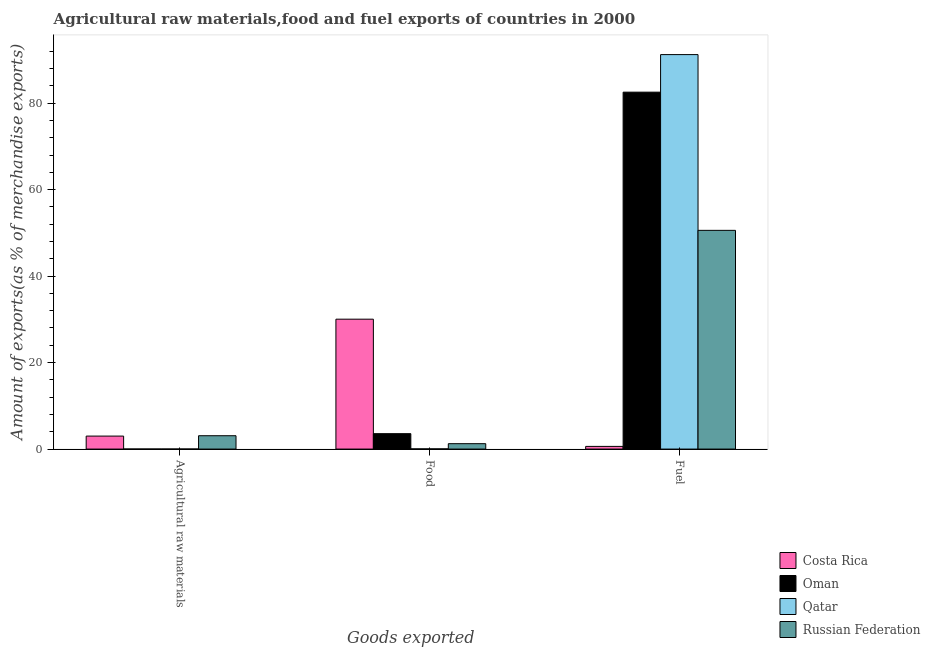How many different coloured bars are there?
Offer a terse response. 4. How many groups of bars are there?
Ensure brevity in your answer.  3. Are the number of bars per tick equal to the number of legend labels?
Make the answer very short. Yes. Are the number of bars on each tick of the X-axis equal?
Offer a very short reply. Yes. What is the label of the 1st group of bars from the left?
Your answer should be compact. Agricultural raw materials. What is the percentage of raw materials exports in Russian Federation?
Your response must be concise. 3.09. Across all countries, what is the maximum percentage of food exports?
Provide a short and direct response. 30.04. Across all countries, what is the minimum percentage of food exports?
Provide a succinct answer. 0.05. In which country was the percentage of raw materials exports maximum?
Provide a short and direct response. Russian Federation. In which country was the percentage of raw materials exports minimum?
Give a very brief answer. Qatar. What is the total percentage of food exports in the graph?
Keep it short and to the point. 34.9. What is the difference between the percentage of fuel exports in Qatar and that in Russian Federation?
Provide a succinct answer. 40.64. What is the difference between the percentage of raw materials exports in Qatar and the percentage of fuel exports in Russian Federation?
Offer a very short reply. -50.57. What is the average percentage of raw materials exports per country?
Make the answer very short. 1.53. What is the difference between the percentage of fuel exports and percentage of food exports in Oman?
Offer a very short reply. 78.97. In how many countries, is the percentage of raw materials exports greater than 12 %?
Keep it short and to the point. 0. What is the ratio of the percentage of fuel exports in Oman to that in Qatar?
Your answer should be compact. 0.9. Is the percentage of fuel exports in Costa Rica less than that in Qatar?
Offer a terse response. Yes. Is the difference between the percentage of food exports in Qatar and Russian Federation greater than the difference between the percentage of fuel exports in Qatar and Russian Federation?
Provide a succinct answer. No. What is the difference between the highest and the second highest percentage of raw materials exports?
Your answer should be very brief. 0.08. What is the difference between the highest and the lowest percentage of raw materials exports?
Provide a succinct answer. 3.08. In how many countries, is the percentage of fuel exports greater than the average percentage of fuel exports taken over all countries?
Your answer should be compact. 2. Is the sum of the percentage of fuel exports in Oman and Russian Federation greater than the maximum percentage of raw materials exports across all countries?
Ensure brevity in your answer.  Yes. What does the 3rd bar from the left in Fuel represents?
Give a very brief answer. Qatar. What does the 2nd bar from the right in Fuel represents?
Your answer should be very brief. Qatar. How many bars are there?
Your response must be concise. 12. Are all the bars in the graph horizontal?
Your answer should be compact. No. Are the values on the major ticks of Y-axis written in scientific E-notation?
Your answer should be very brief. No. Does the graph contain any zero values?
Your response must be concise. No. Does the graph contain grids?
Offer a very short reply. No. Where does the legend appear in the graph?
Keep it short and to the point. Bottom right. How many legend labels are there?
Offer a terse response. 4. What is the title of the graph?
Keep it short and to the point. Agricultural raw materials,food and fuel exports of countries in 2000. What is the label or title of the X-axis?
Offer a very short reply. Goods exported. What is the label or title of the Y-axis?
Your response must be concise. Amount of exports(as % of merchandise exports). What is the Amount of exports(as % of merchandise exports) in Costa Rica in Agricultural raw materials?
Offer a terse response. 3. What is the Amount of exports(as % of merchandise exports) in Oman in Agricultural raw materials?
Your response must be concise. 0.01. What is the Amount of exports(as % of merchandise exports) in Qatar in Agricultural raw materials?
Your response must be concise. 0.01. What is the Amount of exports(as % of merchandise exports) in Russian Federation in Agricultural raw materials?
Your answer should be compact. 3.09. What is the Amount of exports(as % of merchandise exports) in Costa Rica in Food?
Offer a terse response. 30.04. What is the Amount of exports(as % of merchandise exports) of Oman in Food?
Your answer should be compact. 3.56. What is the Amount of exports(as % of merchandise exports) of Qatar in Food?
Make the answer very short. 0.05. What is the Amount of exports(as % of merchandise exports) in Russian Federation in Food?
Your answer should be very brief. 1.25. What is the Amount of exports(as % of merchandise exports) of Costa Rica in Fuel?
Your answer should be very brief. 0.62. What is the Amount of exports(as % of merchandise exports) of Oman in Fuel?
Offer a terse response. 82.54. What is the Amount of exports(as % of merchandise exports) in Qatar in Fuel?
Provide a succinct answer. 91.23. What is the Amount of exports(as % of merchandise exports) in Russian Federation in Fuel?
Your answer should be compact. 50.58. Across all Goods exported, what is the maximum Amount of exports(as % of merchandise exports) of Costa Rica?
Give a very brief answer. 30.04. Across all Goods exported, what is the maximum Amount of exports(as % of merchandise exports) in Oman?
Your answer should be compact. 82.54. Across all Goods exported, what is the maximum Amount of exports(as % of merchandise exports) of Qatar?
Give a very brief answer. 91.23. Across all Goods exported, what is the maximum Amount of exports(as % of merchandise exports) in Russian Federation?
Your answer should be compact. 50.58. Across all Goods exported, what is the minimum Amount of exports(as % of merchandise exports) of Costa Rica?
Your answer should be very brief. 0.62. Across all Goods exported, what is the minimum Amount of exports(as % of merchandise exports) in Oman?
Make the answer very short. 0.01. Across all Goods exported, what is the minimum Amount of exports(as % of merchandise exports) in Qatar?
Your answer should be compact. 0.01. Across all Goods exported, what is the minimum Amount of exports(as % of merchandise exports) in Russian Federation?
Ensure brevity in your answer.  1.25. What is the total Amount of exports(as % of merchandise exports) of Costa Rica in the graph?
Your answer should be very brief. 33.66. What is the total Amount of exports(as % of merchandise exports) of Oman in the graph?
Ensure brevity in your answer.  86.12. What is the total Amount of exports(as % of merchandise exports) in Qatar in the graph?
Offer a terse response. 91.29. What is the total Amount of exports(as % of merchandise exports) of Russian Federation in the graph?
Your response must be concise. 54.92. What is the difference between the Amount of exports(as % of merchandise exports) in Costa Rica in Agricultural raw materials and that in Food?
Your answer should be compact. -27.03. What is the difference between the Amount of exports(as % of merchandise exports) in Oman in Agricultural raw materials and that in Food?
Your response must be concise. -3.55. What is the difference between the Amount of exports(as % of merchandise exports) in Qatar in Agricultural raw materials and that in Food?
Your answer should be compact. -0.03. What is the difference between the Amount of exports(as % of merchandise exports) of Russian Federation in Agricultural raw materials and that in Food?
Offer a very short reply. 1.84. What is the difference between the Amount of exports(as % of merchandise exports) of Costa Rica in Agricultural raw materials and that in Fuel?
Your answer should be very brief. 2.39. What is the difference between the Amount of exports(as % of merchandise exports) in Oman in Agricultural raw materials and that in Fuel?
Offer a terse response. -82.52. What is the difference between the Amount of exports(as % of merchandise exports) in Qatar in Agricultural raw materials and that in Fuel?
Your answer should be compact. -91.21. What is the difference between the Amount of exports(as % of merchandise exports) of Russian Federation in Agricultural raw materials and that in Fuel?
Offer a terse response. -47.49. What is the difference between the Amount of exports(as % of merchandise exports) in Costa Rica in Food and that in Fuel?
Ensure brevity in your answer.  29.42. What is the difference between the Amount of exports(as % of merchandise exports) of Oman in Food and that in Fuel?
Ensure brevity in your answer.  -78.97. What is the difference between the Amount of exports(as % of merchandise exports) in Qatar in Food and that in Fuel?
Keep it short and to the point. -91.18. What is the difference between the Amount of exports(as % of merchandise exports) of Russian Federation in Food and that in Fuel?
Provide a succinct answer. -49.33. What is the difference between the Amount of exports(as % of merchandise exports) in Costa Rica in Agricultural raw materials and the Amount of exports(as % of merchandise exports) in Oman in Food?
Make the answer very short. -0.56. What is the difference between the Amount of exports(as % of merchandise exports) of Costa Rica in Agricultural raw materials and the Amount of exports(as % of merchandise exports) of Qatar in Food?
Offer a terse response. 2.96. What is the difference between the Amount of exports(as % of merchandise exports) in Costa Rica in Agricultural raw materials and the Amount of exports(as % of merchandise exports) in Russian Federation in Food?
Offer a very short reply. 1.76. What is the difference between the Amount of exports(as % of merchandise exports) in Oman in Agricultural raw materials and the Amount of exports(as % of merchandise exports) in Qatar in Food?
Ensure brevity in your answer.  -0.03. What is the difference between the Amount of exports(as % of merchandise exports) in Oman in Agricultural raw materials and the Amount of exports(as % of merchandise exports) in Russian Federation in Food?
Your answer should be very brief. -1.23. What is the difference between the Amount of exports(as % of merchandise exports) in Qatar in Agricultural raw materials and the Amount of exports(as % of merchandise exports) in Russian Federation in Food?
Offer a terse response. -1.23. What is the difference between the Amount of exports(as % of merchandise exports) of Costa Rica in Agricultural raw materials and the Amount of exports(as % of merchandise exports) of Oman in Fuel?
Provide a succinct answer. -79.53. What is the difference between the Amount of exports(as % of merchandise exports) in Costa Rica in Agricultural raw materials and the Amount of exports(as % of merchandise exports) in Qatar in Fuel?
Provide a succinct answer. -88.22. What is the difference between the Amount of exports(as % of merchandise exports) of Costa Rica in Agricultural raw materials and the Amount of exports(as % of merchandise exports) of Russian Federation in Fuel?
Ensure brevity in your answer.  -47.58. What is the difference between the Amount of exports(as % of merchandise exports) in Oman in Agricultural raw materials and the Amount of exports(as % of merchandise exports) in Qatar in Fuel?
Provide a succinct answer. -91.21. What is the difference between the Amount of exports(as % of merchandise exports) of Oman in Agricultural raw materials and the Amount of exports(as % of merchandise exports) of Russian Federation in Fuel?
Provide a succinct answer. -50.57. What is the difference between the Amount of exports(as % of merchandise exports) of Qatar in Agricultural raw materials and the Amount of exports(as % of merchandise exports) of Russian Federation in Fuel?
Your answer should be very brief. -50.57. What is the difference between the Amount of exports(as % of merchandise exports) in Costa Rica in Food and the Amount of exports(as % of merchandise exports) in Oman in Fuel?
Provide a short and direct response. -52.5. What is the difference between the Amount of exports(as % of merchandise exports) in Costa Rica in Food and the Amount of exports(as % of merchandise exports) in Qatar in Fuel?
Make the answer very short. -61.19. What is the difference between the Amount of exports(as % of merchandise exports) in Costa Rica in Food and the Amount of exports(as % of merchandise exports) in Russian Federation in Fuel?
Your response must be concise. -20.54. What is the difference between the Amount of exports(as % of merchandise exports) in Oman in Food and the Amount of exports(as % of merchandise exports) in Qatar in Fuel?
Your answer should be very brief. -87.66. What is the difference between the Amount of exports(as % of merchandise exports) of Oman in Food and the Amount of exports(as % of merchandise exports) of Russian Federation in Fuel?
Your response must be concise. -47.02. What is the difference between the Amount of exports(as % of merchandise exports) in Qatar in Food and the Amount of exports(as % of merchandise exports) in Russian Federation in Fuel?
Provide a short and direct response. -50.53. What is the average Amount of exports(as % of merchandise exports) in Costa Rica per Goods exported?
Give a very brief answer. 11.22. What is the average Amount of exports(as % of merchandise exports) in Oman per Goods exported?
Ensure brevity in your answer.  28.71. What is the average Amount of exports(as % of merchandise exports) of Qatar per Goods exported?
Provide a short and direct response. 30.43. What is the average Amount of exports(as % of merchandise exports) in Russian Federation per Goods exported?
Offer a terse response. 18.31. What is the difference between the Amount of exports(as % of merchandise exports) in Costa Rica and Amount of exports(as % of merchandise exports) in Oman in Agricultural raw materials?
Keep it short and to the point. 2.99. What is the difference between the Amount of exports(as % of merchandise exports) of Costa Rica and Amount of exports(as % of merchandise exports) of Qatar in Agricultural raw materials?
Keep it short and to the point. 2.99. What is the difference between the Amount of exports(as % of merchandise exports) of Costa Rica and Amount of exports(as % of merchandise exports) of Russian Federation in Agricultural raw materials?
Give a very brief answer. -0.09. What is the difference between the Amount of exports(as % of merchandise exports) of Oman and Amount of exports(as % of merchandise exports) of Qatar in Agricultural raw materials?
Make the answer very short. 0. What is the difference between the Amount of exports(as % of merchandise exports) of Oman and Amount of exports(as % of merchandise exports) of Russian Federation in Agricultural raw materials?
Ensure brevity in your answer.  -3.08. What is the difference between the Amount of exports(as % of merchandise exports) in Qatar and Amount of exports(as % of merchandise exports) in Russian Federation in Agricultural raw materials?
Keep it short and to the point. -3.08. What is the difference between the Amount of exports(as % of merchandise exports) in Costa Rica and Amount of exports(as % of merchandise exports) in Oman in Food?
Offer a terse response. 26.47. What is the difference between the Amount of exports(as % of merchandise exports) in Costa Rica and Amount of exports(as % of merchandise exports) in Qatar in Food?
Provide a succinct answer. 29.99. What is the difference between the Amount of exports(as % of merchandise exports) of Costa Rica and Amount of exports(as % of merchandise exports) of Russian Federation in Food?
Offer a terse response. 28.79. What is the difference between the Amount of exports(as % of merchandise exports) of Oman and Amount of exports(as % of merchandise exports) of Qatar in Food?
Offer a terse response. 3.52. What is the difference between the Amount of exports(as % of merchandise exports) of Oman and Amount of exports(as % of merchandise exports) of Russian Federation in Food?
Your answer should be compact. 2.32. What is the difference between the Amount of exports(as % of merchandise exports) in Qatar and Amount of exports(as % of merchandise exports) in Russian Federation in Food?
Your response must be concise. -1.2. What is the difference between the Amount of exports(as % of merchandise exports) of Costa Rica and Amount of exports(as % of merchandise exports) of Oman in Fuel?
Offer a very short reply. -81.92. What is the difference between the Amount of exports(as % of merchandise exports) of Costa Rica and Amount of exports(as % of merchandise exports) of Qatar in Fuel?
Your answer should be compact. -90.61. What is the difference between the Amount of exports(as % of merchandise exports) of Costa Rica and Amount of exports(as % of merchandise exports) of Russian Federation in Fuel?
Provide a short and direct response. -49.96. What is the difference between the Amount of exports(as % of merchandise exports) in Oman and Amount of exports(as % of merchandise exports) in Qatar in Fuel?
Offer a very short reply. -8.69. What is the difference between the Amount of exports(as % of merchandise exports) of Oman and Amount of exports(as % of merchandise exports) of Russian Federation in Fuel?
Your response must be concise. 31.96. What is the difference between the Amount of exports(as % of merchandise exports) in Qatar and Amount of exports(as % of merchandise exports) in Russian Federation in Fuel?
Offer a terse response. 40.64. What is the ratio of the Amount of exports(as % of merchandise exports) in Costa Rica in Agricultural raw materials to that in Food?
Keep it short and to the point. 0.1. What is the ratio of the Amount of exports(as % of merchandise exports) in Oman in Agricultural raw materials to that in Food?
Provide a short and direct response. 0. What is the ratio of the Amount of exports(as % of merchandise exports) of Qatar in Agricultural raw materials to that in Food?
Give a very brief answer. 0.28. What is the ratio of the Amount of exports(as % of merchandise exports) of Russian Federation in Agricultural raw materials to that in Food?
Your answer should be very brief. 2.48. What is the ratio of the Amount of exports(as % of merchandise exports) in Costa Rica in Agricultural raw materials to that in Fuel?
Give a very brief answer. 4.86. What is the ratio of the Amount of exports(as % of merchandise exports) in Qatar in Agricultural raw materials to that in Fuel?
Provide a short and direct response. 0. What is the ratio of the Amount of exports(as % of merchandise exports) in Russian Federation in Agricultural raw materials to that in Fuel?
Provide a short and direct response. 0.06. What is the ratio of the Amount of exports(as % of merchandise exports) of Costa Rica in Food to that in Fuel?
Give a very brief answer. 48.61. What is the ratio of the Amount of exports(as % of merchandise exports) in Oman in Food to that in Fuel?
Ensure brevity in your answer.  0.04. What is the ratio of the Amount of exports(as % of merchandise exports) of Russian Federation in Food to that in Fuel?
Ensure brevity in your answer.  0.02. What is the difference between the highest and the second highest Amount of exports(as % of merchandise exports) in Costa Rica?
Provide a succinct answer. 27.03. What is the difference between the highest and the second highest Amount of exports(as % of merchandise exports) in Oman?
Keep it short and to the point. 78.97. What is the difference between the highest and the second highest Amount of exports(as % of merchandise exports) of Qatar?
Ensure brevity in your answer.  91.18. What is the difference between the highest and the second highest Amount of exports(as % of merchandise exports) of Russian Federation?
Provide a succinct answer. 47.49. What is the difference between the highest and the lowest Amount of exports(as % of merchandise exports) of Costa Rica?
Offer a terse response. 29.42. What is the difference between the highest and the lowest Amount of exports(as % of merchandise exports) of Oman?
Provide a succinct answer. 82.52. What is the difference between the highest and the lowest Amount of exports(as % of merchandise exports) of Qatar?
Make the answer very short. 91.21. What is the difference between the highest and the lowest Amount of exports(as % of merchandise exports) of Russian Federation?
Offer a very short reply. 49.33. 